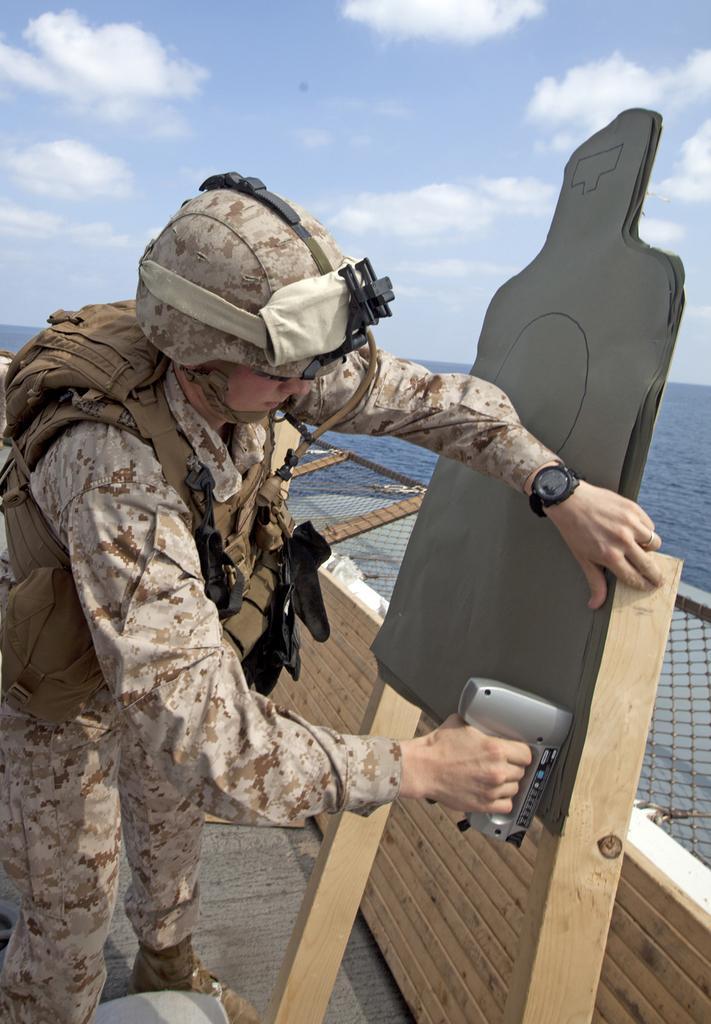How would you summarize this image in a sentence or two? In this image, we can see a person holding some object. We can see the shooting board attached to poles. We can see the wooden wall and the fence. We can also see the ground. We can see some water and the sky with clouds. 